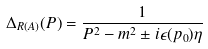<formula> <loc_0><loc_0><loc_500><loc_500>\Delta _ { R ( A ) } ( P ) = \frac { 1 } { P ^ { 2 } - m ^ { 2 } \pm i \epsilon ( p _ { 0 } ) \eta }</formula> 